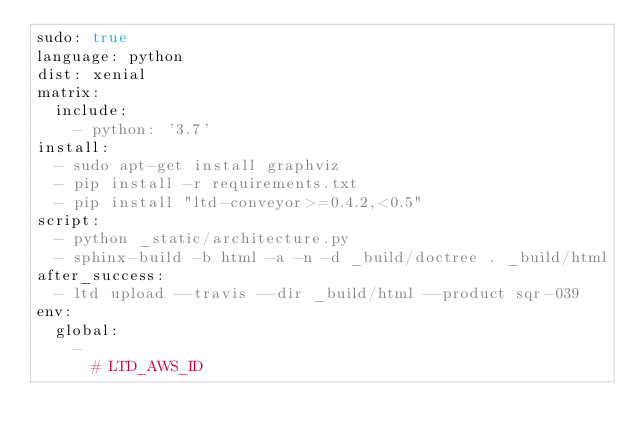Convert code to text. <code><loc_0><loc_0><loc_500><loc_500><_YAML_>sudo: true
language: python
dist: xenial
matrix:
  include:
    - python: '3.7'
install:
  - sudo apt-get install graphviz
  - pip install -r requirements.txt
  - pip install "ltd-conveyor>=0.4.2,<0.5"
script:
  - python _static/architecture.py
  - sphinx-build -b html -a -n -d _build/doctree . _build/html
after_success:
  - ltd upload --travis --dir _build/html --product sqr-039
env:
  global:
    -
      # LTD_AWS_ID</code> 